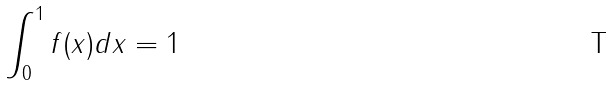Convert formula to latex. <formula><loc_0><loc_0><loc_500><loc_500>\int _ { 0 } ^ { 1 } f ( x ) d x = 1</formula> 